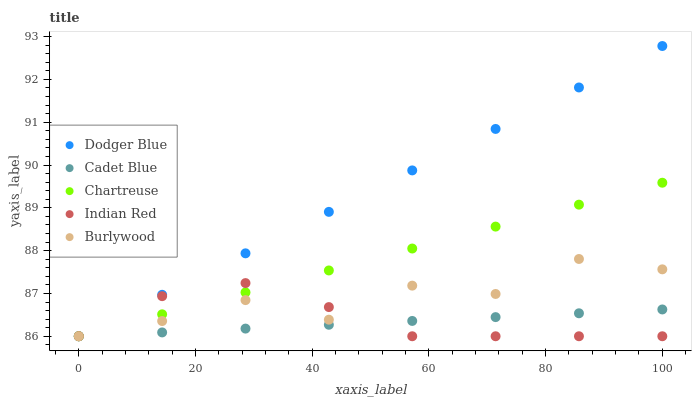Does Cadet Blue have the minimum area under the curve?
Answer yes or no. Yes. Does Dodger Blue have the maximum area under the curve?
Answer yes or no. Yes. Does Chartreuse have the minimum area under the curve?
Answer yes or no. No. Does Chartreuse have the maximum area under the curve?
Answer yes or no. No. Is Cadet Blue the smoothest?
Answer yes or no. Yes. Is Burlywood the roughest?
Answer yes or no. Yes. Is Chartreuse the smoothest?
Answer yes or no. No. Is Chartreuse the roughest?
Answer yes or no. No. Does Burlywood have the lowest value?
Answer yes or no. Yes. Does Dodger Blue have the highest value?
Answer yes or no. Yes. Does Chartreuse have the highest value?
Answer yes or no. No. Does Indian Red intersect Cadet Blue?
Answer yes or no. Yes. Is Indian Red less than Cadet Blue?
Answer yes or no. No. Is Indian Red greater than Cadet Blue?
Answer yes or no. No. 